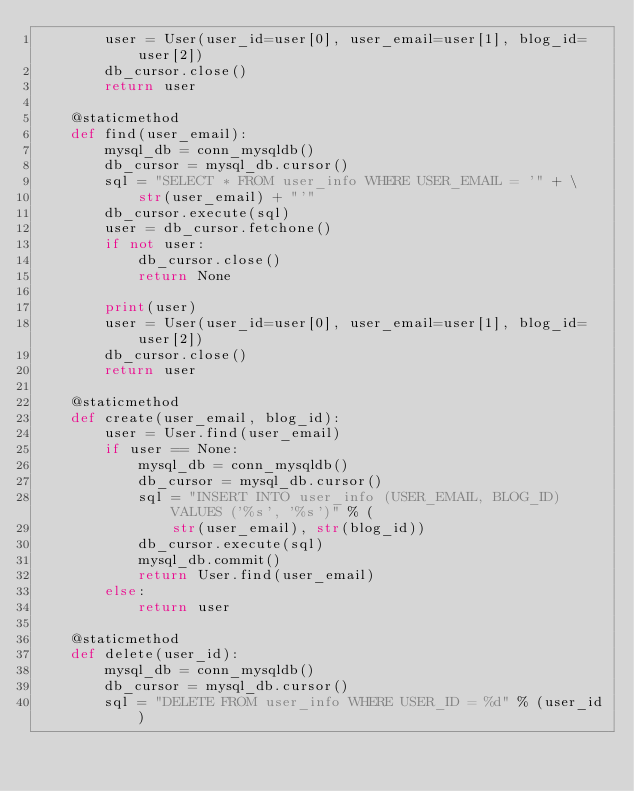Convert code to text. <code><loc_0><loc_0><loc_500><loc_500><_Python_>        user = User(user_id=user[0], user_email=user[1], blog_id=user[2])
        db_cursor.close()
        return user

    @staticmethod
    def find(user_email):
        mysql_db = conn_mysqldb()
        db_cursor = mysql_db.cursor()
        sql = "SELECT * FROM user_info WHERE USER_EMAIL = '" + \
            str(user_email) + "'"
        db_cursor.execute(sql)
        user = db_cursor.fetchone()
        if not user:
            db_cursor.close()
            return None

        print(user)
        user = User(user_id=user[0], user_email=user[1], blog_id=user[2])
        db_cursor.close()
        return user

    @staticmethod
    def create(user_email, blog_id):
        user = User.find(user_email)
        if user == None:
            mysql_db = conn_mysqldb()
            db_cursor = mysql_db.cursor()
            sql = "INSERT INTO user_info (USER_EMAIL, BLOG_ID) VALUES ('%s', '%s')" % (
                str(user_email), str(blog_id))
            db_cursor.execute(sql)
            mysql_db.commit()
            return User.find(user_email)
        else:
            return user

    @staticmethod
    def delete(user_id):
        mysql_db = conn_mysqldb()
        db_cursor = mysql_db.cursor()
        sql = "DELETE FROM user_info WHERE USER_ID = %d" % (user_id)</code> 